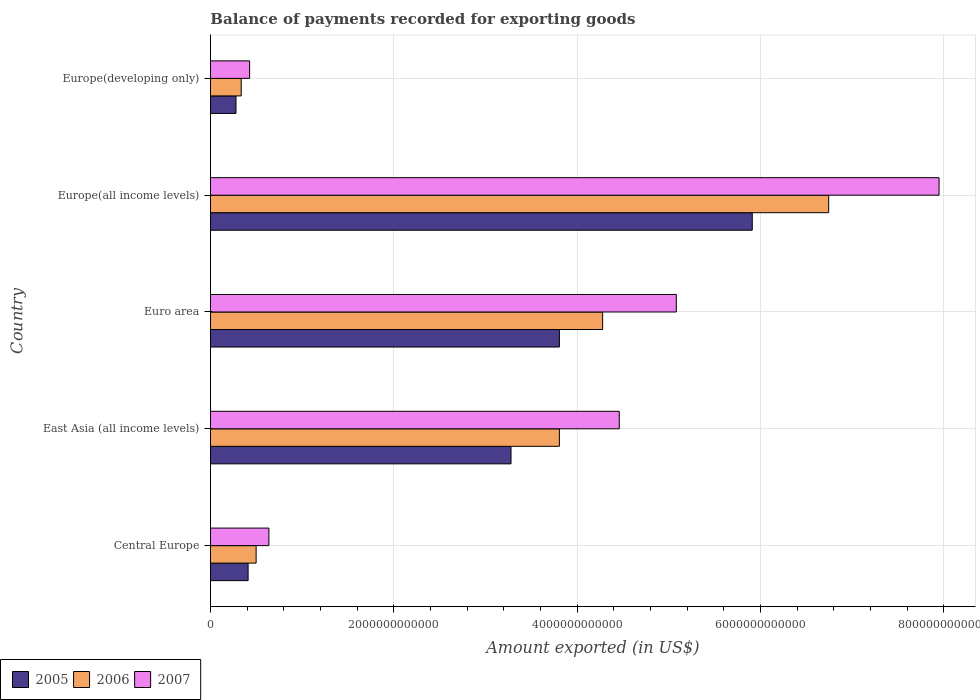How many different coloured bars are there?
Your response must be concise. 3. How many groups of bars are there?
Your answer should be compact. 5. Are the number of bars per tick equal to the number of legend labels?
Provide a succinct answer. Yes. Are the number of bars on each tick of the Y-axis equal?
Your response must be concise. Yes. How many bars are there on the 3rd tick from the top?
Make the answer very short. 3. What is the label of the 3rd group of bars from the top?
Ensure brevity in your answer.  Euro area. What is the amount exported in 2005 in East Asia (all income levels)?
Give a very brief answer. 3.28e+12. Across all countries, what is the maximum amount exported in 2006?
Provide a succinct answer. 6.74e+12. Across all countries, what is the minimum amount exported in 2005?
Provide a short and direct response. 2.78e+11. In which country was the amount exported in 2006 maximum?
Your response must be concise. Europe(all income levels). In which country was the amount exported in 2005 minimum?
Provide a succinct answer. Europe(developing only). What is the total amount exported in 2006 in the graph?
Provide a succinct answer. 1.57e+13. What is the difference between the amount exported in 2005 in Central Europe and that in Euro area?
Your answer should be compact. -3.40e+12. What is the difference between the amount exported in 2007 in Europe(all income levels) and the amount exported in 2005 in Central Europe?
Provide a short and direct response. 7.54e+12. What is the average amount exported in 2006 per country?
Your answer should be compact. 3.13e+12. What is the difference between the amount exported in 2005 and amount exported in 2006 in Euro area?
Give a very brief answer. -4.72e+11. What is the ratio of the amount exported in 2005 in Euro area to that in Europe(all income levels)?
Ensure brevity in your answer.  0.64. What is the difference between the highest and the second highest amount exported in 2006?
Ensure brevity in your answer.  2.47e+12. What is the difference between the highest and the lowest amount exported in 2005?
Offer a very short reply. 5.63e+12. Is the sum of the amount exported in 2006 in Europe(all income levels) and Europe(developing only) greater than the maximum amount exported in 2005 across all countries?
Make the answer very short. Yes. What does the 2nd bar from the bottom in Central Europe represents?
Offer a very short reply. 2006. Is it the case that in every country, the sum of the amount exported in 2006 and amount exported in 2007 is greater than the amount exported in 2005?
Offer a terse response. Yes. How many countries are there in the graph?
Provide a succinct answer. 5. What is the difference between two consecutive major ticks on the X-axis?
Provide a succinct answer. 2.00e+12. Are the values on the major ticks of X-axis written in scientific E-notation?
Give a very brief answer. No. How many legend labels are there?
Make the answer very short. 3. How are the legend labels stacked?
Provide a succinct answer. Horizontal. What is the title of the graph?
Make the answer very short. Balance of payments recorded for exporting goods. What is the label or title of the X-axis?
Keep it short and to the point. Amount exported (in US$). What is the label or title of the Y-axis?
Provide a short and direct response. Country. What is the Amount exported (in US$) in 2005 in Central Europe?
Ensure brevity in your answer.  4.11e+11. What is the Amount exported (in US$) of 2006 in Central Europe?
Give a very brief answer. 4.98e+11. What is the Amount exported (in US$) of 2007 in Central Europe?
Your answer should be compact. 6.37e+11. What is the Amount exported (in US$) of 2005 in East Asia (all income levels)?
Your answer should be very brief. 3.28e+12. What is the Amount exported (in US$) in 2006 in East Asia (all income levels)?
Your response must be concise. 3.81e+12. What is the Amount exported (in US$) of 2007 in East Asia (all income levels)?
Your answer should be very brief. 4.46e+12. What is the Amount exported (in US$) in 2005 in Euro area?
Make the answer very short. 3.81e+12. What is the Amount exported (in US$) in 2006 in Euro area?
Make the answer very short. 4.28e+12. What is the Amount exported (in US$) in 2007 in Euro area?
Your response must be concise. 5.08e+12. What is the Amount exported (in US$) in 2005 in Europe(all income levels)?
Provide a short and direct response. 5.91e+12. What is the Amount exported (in US$) of 2006 in Europe(all income levels)?
Your response must be concise. 6.74e+12. What is the Amount exported (in US$) of 2007 in Europe(all income levels)?
Your answer should be compact. 7.95e+12. What is the Amount exported (in US$) of 2005 in Europe(developing only)?
Offer a very short reply. 2.78e+11. What is the Amount exported (in US$) of 2006 in Europe(developing only)?
Provide a short and direct response. 3.35e+11. What is the Amount exported (in US$) in 2007 in Europe(developing only)?
Keep it short and to the point. 4.27e+11. Across all countries, what is the maximum Amount exported (in US$) of 2005?
Provide a short and direct response. 5.91e+12. Across all countries, what is the maximum Amount exported (in US$) of 2006?
Your answer should be very brief. 6.74e+12. Across all countries, what is the maximum Amount exported (in US$) of 2007?
Offer a terse response. 7.95e+12. Across all countries, what is the minimum Amount exported (in US$) of 2005?
Keep it short and to the point. 2.78e+11. Across all countries, what is the minimum Amount exported (in US$) in 2006?
Provide a short and direct response. 3.35e+11. Across all countries, what is the minimum Amount exported (in US$) of 2007?
Provide a succinct answer. 4.27e+11. What is the total Amount exported (in US$) of 2005 in the graph?
Your answer should be very brief. 1.37e+13. What is the total Amount exported (in US$) of 2006 in the graph?
Offer a terse response. 1.57e+13. What is the total Amount exported (in US$) of 2007 in the graph?
Your answer should be very brief. 1.86e+13. What is the difference between the Amount exported (in US$) in 2005 in Central Europe and that in East Asia (all income levels)?
Give a very brief answer. -2.87e+12. What is the difference between the Amount exported (in US$) in 2006 in Central Europe and that in East Asia (all income levels)?
Ensure brevity in your answer.  -3.31e+12. What is the difference between the Amount exported (in US$) in 2007 in Central Europe and that in East Asia (all income levels)?
Give a very brief answer. -3.82e+12. What is the difference between the Amount exported (in US$) of 2005 in Central Europe and that in Euro area?
Your response must be concise. -3.40e+12. What is the difference between the Amount exported (in US$) in 2006 in Central Europe and that in Euro area?
Make the answer very short. -3.78e+12. What is the difference between the Amount exported (in US$) of 2007 in Central Europe and that in Euro area?
Provide a succinct answer. -4.44e+12. What is the difference between the Amount exported (in US$) of 2005 in Central Europe and that in Europe(all income levels)?
Your response must be concise. -5.50e+12. What is the difference between the Amount exported (in US$) of 2006 in Central Europe and that in Europe(all income levels)?
Make the answer very short. -6.25e+12. What is the difference between the Amount exported (in US$) of 2007 in Central Europe and that in Europe(all income levels)?
Make the answer very short. -7.31e+12. What is the difference between the Amount exported (in US$) of 2005 in Central Europe and that in Europe(developing only)?
Your answer should be compact. 1.32e+11. What is the difference between the Amount exported (in US$) in 2006 in Central Europe and that in Europe(developing only)?
Keep it short and to the point. 1.63e+11. What is the difference between the Amount exported (in US$) in 2007 in Central Europe and that in Europe(developing only)?
Your answer should be very brief. 2.10e+11. What is the difference between the Amount exported (in US$) in 2005 in East Asia (all income levels) and that in Euro area?
Your answer should be compact. -5.28e+11. What is the difference between the Amount exported (in US$) of 2006 in East Asia (all income levels) and that in Euro area?
Provide a short and direct response. -4.72e+11. What is the difference between the Amount exported (in US$) in 2007 in East Asia (all income levels) and that in Euro area?
Provide a succinct answer. -6.22e+11. What is the difference between the Amount exported (in US$) of 2005 in East Asia (all income levels) and that in Europe(all income levels)?
Keep it short and to the point. -2.63e+12. What is the difference between the Amount exported (in US$) in 2006 in East Asia (all income levels) and that in Europe(all income levels)?
Make the answer very short. -2.94e+12. What is the difference between the Amount exported (in US$) in 2007 in East Asia (all income levels) and that in Europe(all income levels)?
Provide a succinct answer. -3.49e+12. What is the difference between the Amount exported (in US$) in 2005 in East Asia (all income levels) and that in Europe(developing only)?
Ensure brevity in your answer.  3.00e+12. What is the difference between the Amount exported (in US$) of 2006 in East Asia (all income levels) and that in Europe(developing only)?
Ensure brevity in your answer.  3.47e+12. What is the difference between the Amount exported (in US$) of 2007 in East Asia (all income levels) and that in Europe(developing only)?
Your answer should be very brief. 4.03e+12. What is the difference between the Amount exported (in US$) in 2005 in Euro area and that in Europe(all income levels)?
Your response must be concise. -2.10e+12. What is the difference between the Amount exported (in US$) of 2006 in Euro area and that in Europe(all income levels)?
Offer a very short reply. -2.47e+12. What is the difference between the Amount exported (in US$) in 2007 in Euro area and that in Europe(all income levels)?
Your response must be concise. -2.87e+12. What is the difference between the Amount exported (in US$) in 2005 in Euro area and that in Europe(developing only)?
Give a very brief answer. 3.53e+12. What is the difference between the Amount exported (in US$) of 2006 in Euro area and that in Europe(developing only)?
Provide a succinct answer. 3.94e+12. What is the difference between the Amount exported (in US$) in 2007 in Euro area and that in Europe(developing only)?
Your answer should be compact. 4.65e+12. What is the difference between the Amount exported (in US$) in 2005 in Europe(all income levels) and that in Europe(developing only)?
Give a very brief answer. 5.63e+12. What is the difference between the Amount exported (in US$) of 2006 in Europe(all income levels) and that in Europe(developing only)?
Provide a short and direct response. 6.41e+12. What is the difference between the Amount exported (in US$) of 2007 in Europe(all income levels) and that in Europe(developing only)?
Provide a succinct answer. 7.52e+12. What is the difference between the Amount exported (in US$) of 2005 in Central Europe and the Amount exported (in US$) of 2006 in East Asia (all income levels)?
Make the answer very short. -3.40e+12. What is the difference between the Amount exported (in US$) of 2005 in Central Europe and the Amount exported (in US$) of 2007 in East Asia (all income levels)?
Your answer should be very brief. -4.05e+12. What is the difference between the Amount exported (in US$) of 2006 in Central Europe and the Amount exported (in US$) of 2007 in East Asia (all income levels)?
Give a very brief answer. -3.96e+12. What is the difference between the Amount exported (in US$) in 2005 in Central Europe and the Amount exported (in US$) in 2006 in Euro area?
Your answer should be very brief. -3.87e+12. What is the difference between the Amount exported (in US$) of 2005 in Central Europe and the Amount exported (in US$) of 2007 in Euro area?
Offer a very short reply. -4.67e+12. What is the difference between the Amount exported (in US$) in 2006 in Central Europe and the Amount exported (in US$) in 2007 in Euro area?
Keep it short and to the point. -4.58e+12. What is the difference between the Amount exported (in US$) in 2005 in Central Europe and the Amount exported (in US$) in 2006 in Europe(all income levels)?
Offer a very short reply. -6.33e+12. What is the difference between the Amount exported (in US$) of 2005 in Central Europe and the Amount exported (in US$) of 2007 in Europe(all income levels)?
Your answer should be very brief. -7.54e+12. What is the difference between the Amount exported (in US$) of 2006 in Central Europe and the Amount exported (in US$) of 2007 in Europe(all income levels)?
Ensure brevity in your answer.  -7.45e+12. What is the difference between the Amount exported (in US$) of 2005 in Central Europe and the Amount exported (in US$) of 2006 in Europe(developing only)?
Ensure brevity in your answer.  7.52e+1. What is the difference between the Amount exported (in US$) in 2005 in Central Europe and the Amount exported (in US$) in 2007 in Europe(developing only)?
Your answer should be compact. -1.65e+1. What is the difference between the Amount exported (in US$) of 2006 in Central Europe and the Amount exported (in US$) of 2007 in Europe(developing only)?
Your answer should be compact. 7.09e+1. What is the difference between the Amount exported (in US$) in 2005 in East Asia (all income levels) and the Amount exported (in US$) in 2006 in Euro area?
Offer a very short reply. -1.00e+12. What is the difference between the Amount exported (in US$) in 2005 in East Asia (all income levels) and the Amount exported (in US$) in 2007 in Euro area?
Your answer should be compact. -1.80e+12. What is the difference between the Amount exported (in US$) of 2006 in East Asia (all income levels) and the Amount exported (in US$) of 2007 in Euro area?
Keep it short and to the point. -1.28e+12. What is the difference between the Amount exported (in US$) of 2005 in East Asia (all income levels) and the Amount exported (in US$) of 2006 in Europe(all income levels)?
Your answer should be compact. -3.47e+12. What is the difference between the Amount exported (in US$) of 2005 in East Asia (all income levels) and the Amount exported (in US$) of 2007 in Europe(all income levels)?
Your answer should be very brief. -4.67e+12. What is the difference between the Amount exported (in US$) of 2006 in East Asia (all income levels) and the Amount exported (in US$) of 2007 in Europe(all income levels)?
Your response must be concise. -4.14e+12. What is the difference between the Amount exported (in US$) of 2005 in East Asia (all income levels) and the Amount exported (in US$) of 2006 in Europe(developing only)?
Offer a very short reply. 2.94e+12. What is the difference between the Amount exported (in US$) in 2005 in East Asia (all income levels) and the Amount exported (in US$) in 2007 in Europe(developing only)?
Ensure brevity in your answer.  2.85e+12. What is the difference between the Amount exported (in US$) in 2006 in East Asia (all income levels) and the Amount exported (in US$) in 2007 in Europe(developing only)?
Your answer should be compact. 3.38e+12. What is the difference between the Amount exported (in US$) in 2005 in Euro area and the Amount exported (in US$) in 2006 in Europe(all income levels)?
Provide a succinct answer. -2.94e+12. What is the difference between the Amount exported (in US$) in 2005 in Euro area and the Amount exported (in US$) in 2007 in Europe(all income levels)?
Offer a terse response. -4.14e+12. What is the difference between the Amount exported (in US$) of 2006 in Euro area and the Amount exported (in US$) of 2007 in Europe(all income levels)?
Ensure brevity in your answer.  -3.67e+12. What is the difference between the Amount exported (in US$) of 2005 in Euro area and the Amount exported (in US$) of 2006 in Europe(developing only)?
Ensure brevity in your answer.  3.47e+12. What is the difference between the Amount exported (in US$) of 2005 in Euro area and the Amount exported (in US$) of 2007 in Europe(developing only)?
Provide a succinct answer. 3.38e+12. What is the difference between the Amount exported (in US$) in 2006 in Euro area and the Amount exported (in US$) in 2007 in Europe(developing only)?
Your response must be concise. 3.85e+12. What is the difference between the Amount exported (in US$) of 2005 in Europe(all income levels) and the Amount exported (in US$) of 2006 in Europe(developing only)?
Ensure brevity in your answer.  5.58e+12. What is the difference between the Amount exported (in US$) in 2005 in Europe(all income levels) and the Amount exported (in US$) in 2007 in Europe(developing only)?
Give a very brief answer. 5.48e+12. What is the difference between the Amount exported (in US$) of 2006 in Europe(all income levels) and the Amount exported (in US$) of 2007 in Europe(developing only)?
Your answer should be compact. 6.32e+12. What is the average Amount exported (in US$) of 2005 per country?
Offer a very short reply. 2.74e+12. What is the average Amount exported (in US$) in 2006 per country?
Provide a short and direct response. 3.13e+12. What is the average Amount exported (in US$) in 2007 per country?
Give a very brief answer. 3.71e+12. What is the difference between the Amount exported (in US$) of 2005 and Amount exported (in US$) of 2006 in Central Europe?
Your response must be concise. -8.74e+1. What is the difference between the Amount exported (in US$) of 2005 and Amount exported (in US$) of 2007 in Central Europe?
Keep it short and to the point. -2.27e+11. What is the difference between the Amount exported (in US$) of 2006 and Amount exported (in US$) of 2007 in Central Europe?
Offer a terse response. -1.39e+11. What is the difference between the Amount exported (in US$) of 2005 and Amount exported (in US$) of 2006 in East Asia (all income levels)?
Give a very brief answer. -5.28e+11. What is the difference between the Amount exported (in US$) in 2005 and Amount exported (in US$) in 2007 in East Asia (all income levels)?
Offer a very short reply. -1.18e+12. What is the difference between the Amount exported (in US$) of 2006 and Amount exported (in US$) of 2007 in East Asia (all income levels)?
Your answer should be very brief. -6.53e+11. What is the difference between the Amount exported (in US$) in 2005 and Amount exported (in US$) in 2006 in Euro area?
Your response must be concise. -4.72e+11. What is the difference between the Amount exported (in US$) of 2005 and Amount exported (in US$) of 2007 in Euro area?
Your answer should be very brief. -1.28e+12. What is the difference between the Amount exported (in US$) of 2006 and Amount exported (in US$) of 2007 in Euro area?
Make the answer very short. -8.04e+11. What is the difference between the Amount exported (in US$) of 2005 and Amount exported (in US$) of 2006 in Europe(all income levels)?
Offer a terse response. -8.34e+11. What is the difference between the Amount exported (in US$) of 2005 and Amount exported (in US$) of 2007 in Europe(all income levels)?
Provide a succinct answer. -2.04e+12. What is the difference between the Amount exported (in US$) of 2006 and Amount exported (in US$) of 2007 in Europe(all income levels)?
Ensure brevity in your answer.  -1.20e+12. What is the difference between the Amount exported (in US$) of 2005 and Amount exported (in US$) of 2006 in Europe(developing only)?
Your response must be concise. -5.70e+1. What is the difference between the Amount exported (in US$) of 2005 and Amount exported (in US$) of 2007 in Europe(developing only)?
Offer a terse response. -1.49e+11. What is the difference between the Amount exported (in US$) of 2006 and Amount exported (in US$) of 2007 in Europe(developing only)?
Offer a very short reply. -9.17e+1. What is the ratio of the Amount exported (in US$) of 2005 in Central Europe to that in East Asia (all income levels)?
Your answer should be very brief. 0.13. What is the ratio of the Amount exported (in US$) in 2006 in Central Europe to that in East Asia (all income levels)?
Offer a terse response. 0.13. What is the ratio of the Amount exported (in US$) in 2007 in Central Europe to that in East Asia (all income levels)?
Your response must be concise. 0.14. What is the ratio of the Amount exported (in US$) in 2005 in Central Europe to that in Euro area?
Offer a very short reply. 0.11. What is the ratio of the Amount exported (in US$) in 2006 in Central Europe to that in Euro area?
Offer a terse response. 0.12. What is the ratio of the Amount exported (in US$) of 2007 in Central Europe to that in Euro area?
Give a very brief answer. 0.13. What is the ratio of the Amount exported (in US$) in 2005 in Central Europe to that in Europe(all income levels)?
Your answer should be very brief. 0.07. What is the ratio of the Amount exported (in US$) of 2006 in Central Europe to that in Europe(all income levels)?
Your answer should be very brief. 0.07. What is the ratio of the Amount exported (in US$) of 2007 in Central Europe to that in Europe(all income levels)?
Offer a terse response. 0.08. What is the ratio of the Amount exported (in US$) in 2005 in Central Europe to that in Europe(developing only)?
Your answer should be compact. 1.47. What is the ratio of the Amount exported (in US$) of 2006 in Central Europe to that in Europe(developing only)?
Make the answer very short. 1.48. What is the ratio of the Amount exported (in US$) in 2007 in Central Europe to that in Europe(developing only)?
Offer a terse response. 1.49. What is the ratio of the Amount exported (in US$) in 2005 in East Asia (all income levels) to that in Euro area?
Keep it short and to the point. 0.86. What is the ratio of the Amount exported (in US$) in 2006 in East Asia (all income levels) to that in Euro area?
Give a very brief answer. 0.89. What is the ratio of the Amount exported (in US$) of 2007 in East Asia (all income levels) to that in Euro area?
Offer a terse response. 0.88. What is the ratio of the Amount exported (in US$) in 2005 in East Asia (all income levels) to that in Europe(all income levels)?
Ensure brevity in your answer.  0.55. What is the ratio of the Amount exported (in US$) of 2006 in East Asia (all income levels) to that in Europe(all income levels)?
Your answer should be very brief. 0.56. What is the ratio of the Amount exported (in US$) of 2007 in East Asia (all income levels) to that in Europe(all income levels)?
Give a very brief answer. 0.56. What is the ratio of the Amount exported (in US$) in 2005 in East Asia (all income levels) to that in Europe(developing only)?
Your answer should be very brief. 11.78. What is the ratio of the Amount exported (in US$) of 2006 in East Asia (all income levels) to that in Europe(developing only)?
Keep it short and to the point. 11.35. What is the ratio of the Amount exported (in US$) in 2007 in East Asia (all income levels) to that in Europe(developing only)?
Keep it short and to the point. 10.44. What is the ratio of the Amount exported (in US$) in 2005 in Euro area to that in Europe(all income levels)?
Keep it short and to the point. 0.64. What is the ratio of the Amount exported (in US$) in 2006 in Euro area to that in Europe(all income levels)?
Make the answer very short. 0.63. What is the ratio of the Amount exported (in US$) in 2007 in Euro area to that in Europe(all income levels)?
Give a very brief answer. 0.64. What is the ratio of the Amount exported (in US$) in 2005 in Euro area to that in Europe(developing only)?
Ensure brevity in your answer.  13.67. What is the ratio of the Amount exported (in US$) in 2006 in Euro area to that in Europe(developing only)?
Keep it short and to the point. 12.76. What is the ratio of the Amount exported (in US$) of 2007 in Euro area to that in Europe(developing only)?
Your answer should be very brief. 11.9. What is the ratio of the Amount exported (in US$) in 2005 in Europe(all income levels) to that in Europe(developing only)?
Keep it short and to the point. 21.23. What is the ratio of the Amount exported (in US$) of 2006 in Europe(all income levels) to that in Europe(developing only)?
Offer a terse response. 20.11. What is the ratio of the Amount exported (in US$) of 2007 in Europe(all income levels) to that in Europe(developing only)?
Make the answer very short. 18.61. What is the difference between the highest and the second highest Amount exported (in US$) of 2005?
Offer a terse response. 2.10e+12. What is the difference between the highest and the second highest Amount exported (in US$) of 2006?
Ensure brevity in your answer.  2.47e+12. What is the difference between the highest and the second highest Amount exported (in US$) in 2007?
Ensure brevity in your answer.  2.87e+12. What is the difference between the highest and the lowest Amount exported (in US$) in 2005?
Offer a very short reply. 5.63e+12. What is the difference between the highest and the lowest Amount exported (in US$) of 2006?
Give a very brief answer. 6.41e+12. What is the difference between the highest and the lowest Amount exported (in US$) in 2007?
Your answer should be very brief. 7.52e+12. 